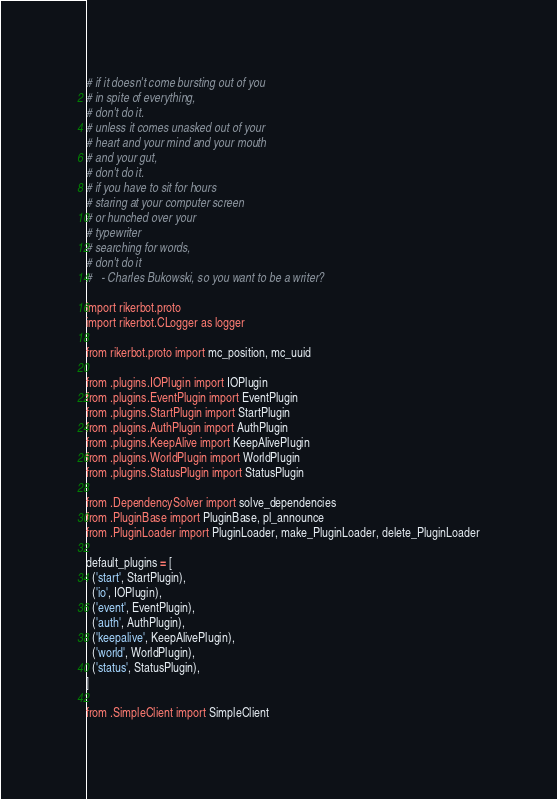Convert code to text. <code><loc_0><loc_0><loc_500><loc_500><_Python_># if it doesn't come bursting out of you
# in spite of everything,
# don't do it.
# unless it comes unasked out of your
# heart and your mind and your mouth
# and your gut,
# don't do it.
# if you have to sit for hours
# staring at your computer screen
# or hunched over your
# typewriter
# searching for words,
# don't do it
#   - Charles Bukowski, so you want to be a writer?

import rikerbot.proto
import rikerbot.CLogger as logger

from rikerbot.proto import mc_position, mc_uuid

from .plugins.IOPlugin import IOPlugin
from .plugins.EventPlugin import EventPlugin
from .plugins.StartPlugin import StartPlugin
from .plugins.AuthPlugin import AuthPlugin
from .plugins.KeepAlive import KeepAlivePlugin
from .plugins.WorldPlugin import WorldPlugin
from .plugins.StatusPlugin import StatusPlugin

from .DependencySolver import solve_dependencies
from .PluginBase import PluginBase, pl_announce
from .PluginLoader import PluginLoader, make_PluginLoader, delete_PluginLoader

default_plugins = [
  ('start', StartPlugin),
  ('io', IOPlugin),
  ('event', EventPlugin),
  ('auth', AuthPlugin),
  ('keepalive', KeepAlivePlugin),
  ('world', WorldPlugin),
  ('status', StatusPlugin),
]

from .SimpleClient import SimpleClient
</code> 